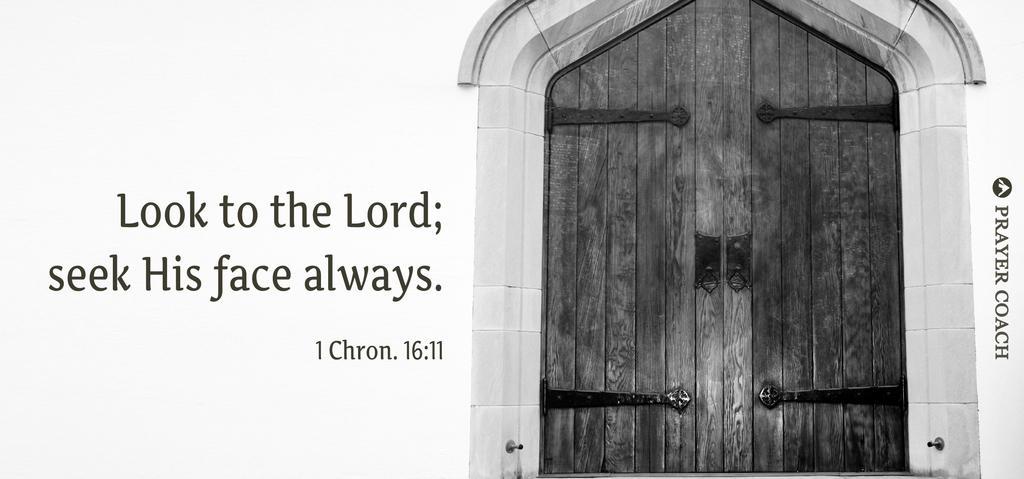Could you give a brief overview of what you see in this image? In this image I can see a door on the right side and on the left side I can see something is written. I can also see something is written on the right side of this image. I can see this image is black and white in colour. 